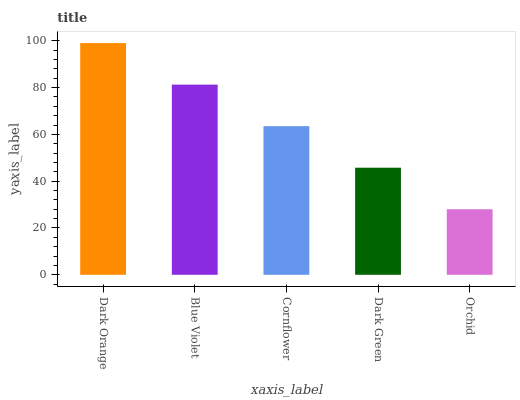Is Orchid the minimum?
Answer yes or no. Yes. Is Dark Orange the maximum?
Answer yes or no. Yes. Is Blue Violet the minimum?
Answer yes or no. No. Is Blue Violet the maximum?
Answer yes or no. No. Is Dark Orange greater than Blue Violet?
Answer yes or no. Yes. Is Blue Violet less than Dark Orange?
Answer yes or no. Yes. Is Blue Violet greater than Dark Orange?
Answer yes or no. No. Is Dark Orange less than Blue Violet?
Answer yes or no. No. Is Cornflower the high median?
Answer yes or no. Yes. Is Cornflower the low median?
Answer yes or no. Yes. Is Blue Violet the high median?
Answer yes or no. No. Is Blue Violet the low median?
Answer yes or no. No. 